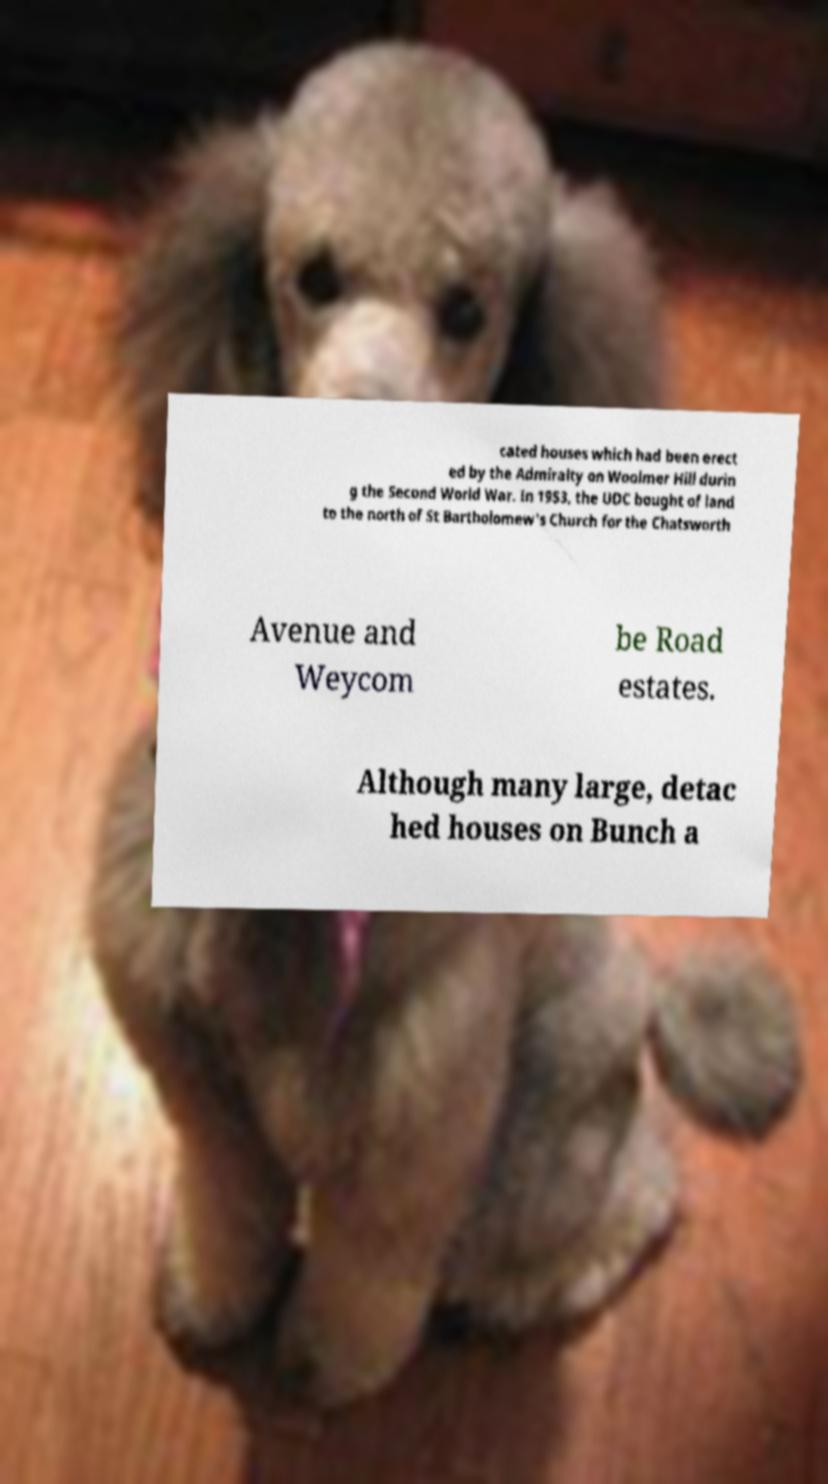I need the written content from this picture converted into text. Can you do that? cated houses which had been erect ed by the Admiralty on Woolmer Hill durin g the Second World War. In 1953, the UDC bought of land to the north of St Bartholomew's Church for the Chatsworth Avenue and Weycom be Road estates. Although many large, detac hed houses on Bunch a 